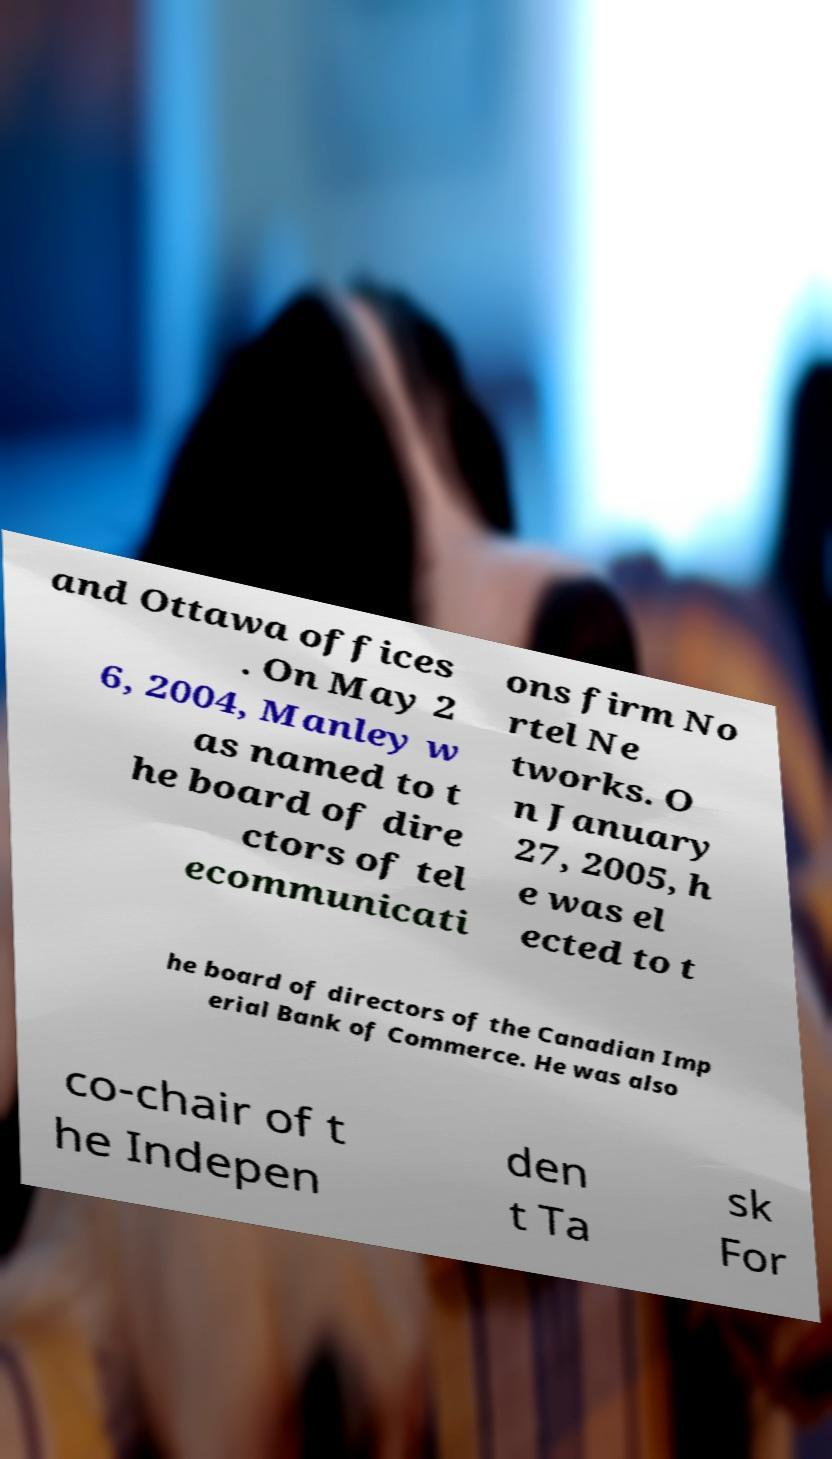Please read and relay the text visible in this image. What does it say? and Ottawa offices . On May 2 6, 2004, Manley w as named to t he board of dire ctors of tel ecommunicati ons firm No rtel Ne tworks. O n January 27, 2005, h e was el ected to t he board of directors of the Canadian Imp erial Bank of Commerce. He was also co-chair of t he Indepen den t Ta sk For 